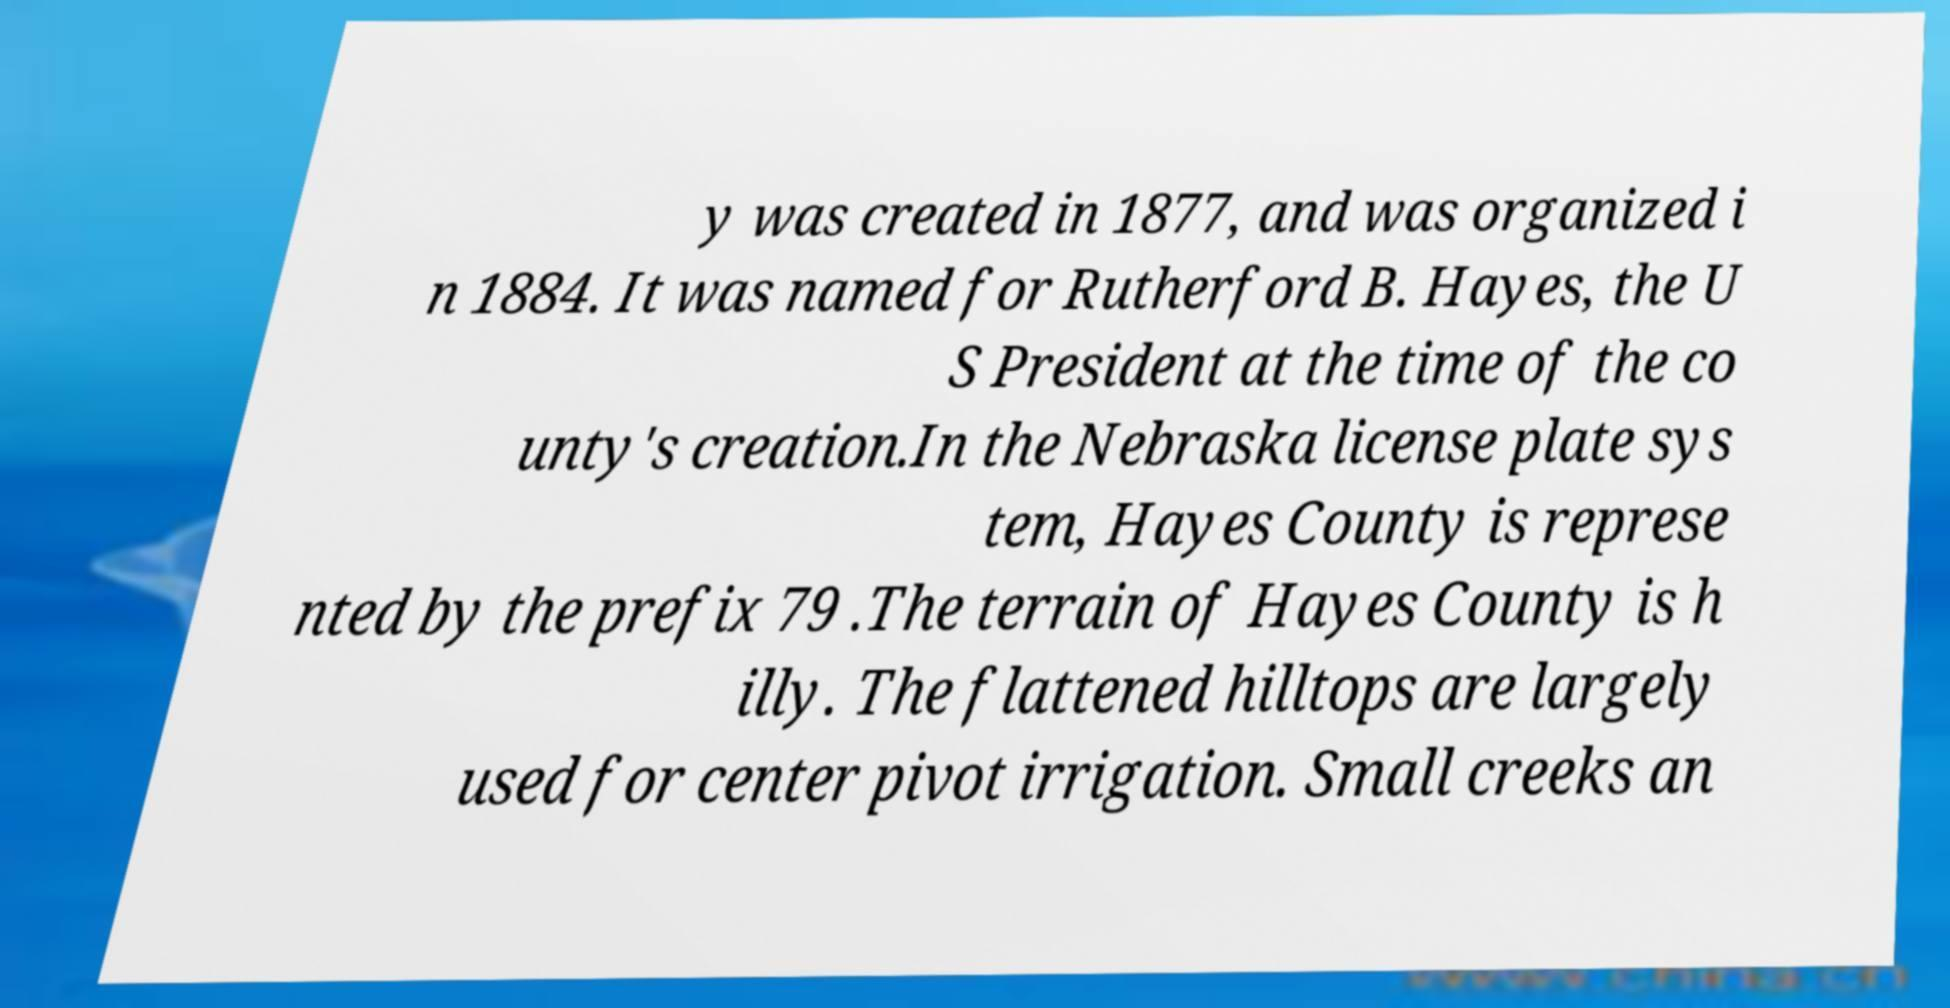Could you extract and type out the text from this image? y was created in 1877, and was organized i n 1884. It was named for Rutherford B. Hayes, the U S President at the time of the co unty's creation.In the Nebraska license plate sys tem, Hayes County is represe nted by the prefix 79 .The terrain of Hayes County is h illy. The flattened hilltops are largely used for center pivot irrigation. Small creeks an 